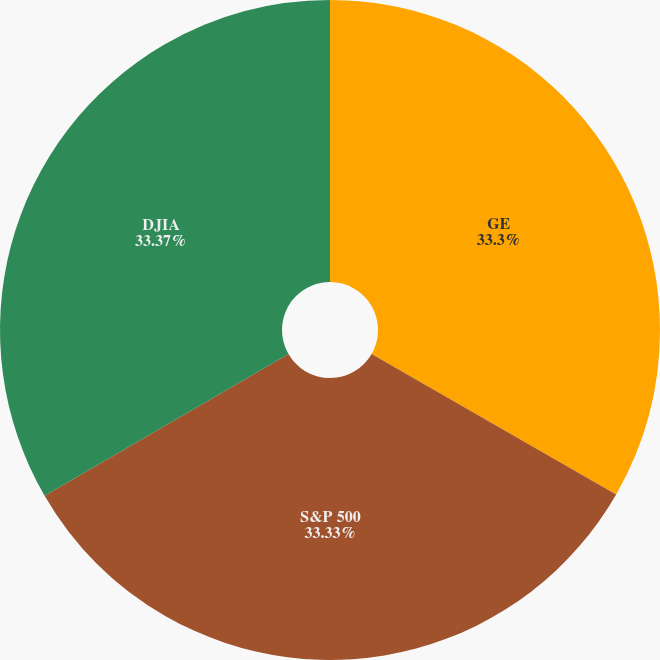Convert chart. <chart><loc_0><loc_0><loc_500><loc_500><pie_chart><fcel>GE<fcel>S&P 500<fcel>DJIA<nl><fcel>33.3%<fcel>33.33%<fcel>33.37%<nl></chart> 